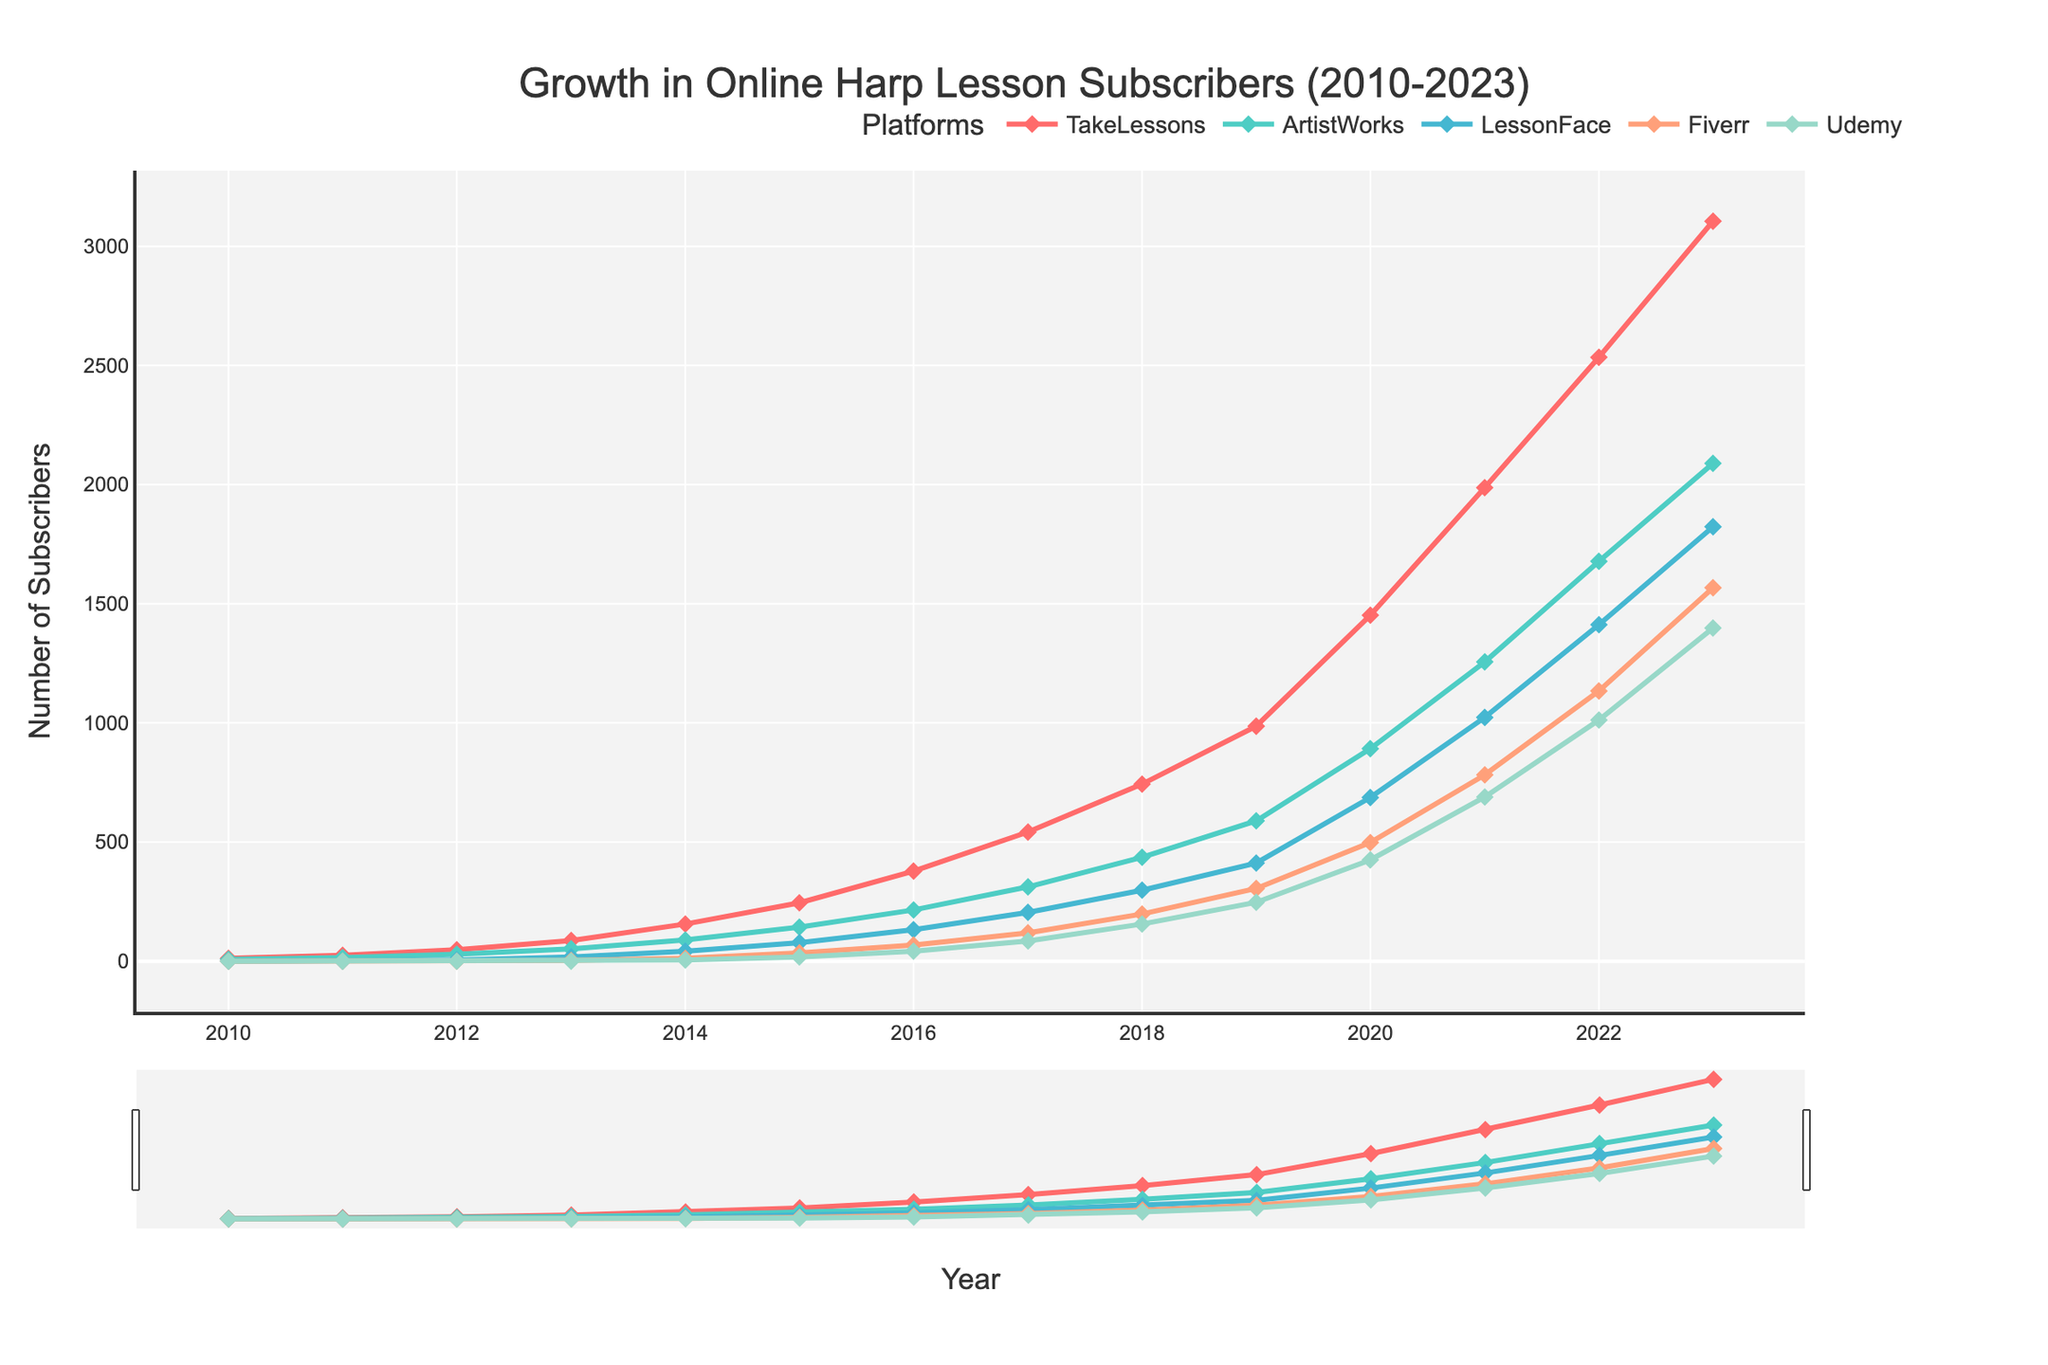What is the total number of subscribers for all platforms in 2023? Sum the subscribers for each platform in 2023: TakeLessons (3105), ArtistWorks (2089), LessonFace (1823), Fiverr (1567), Udemy (1398). Total = 3105 + 2089 + 1823 + 1567 + 1398 = 9982.
Answer: 9982 Which platform had the highest growth in subscribers between 2022 and 2023? Compare the increase in subscribers from 2022 to 2023 for all platforms. TakeLessons increased by 571 (3105-2534), ArtistWorks by 411 (2089-1678), LessonFace by 411 (1823-1412), Fiverr by 433 (1567-1134), and Udemy by 386 (1398-1012). Fiverr had the highest increase of 433 subscribers.
Answer: Fiverr Between which two consecutive years did TakeLessons see the largest growth? Calculate the differences between consecutive years for TakeLessons: 2011 (13), 2012 (23), 2013 (39), 2014 (69), 2015 (89), 2016 (133), 2017 (164), 2018 (201), 2019 (243), 2020 (466), 2021 (535), 2022 (547), 2023 (571). The largest growth was between 2019 and 2020 (466).
Answer: 2019 and 2020 Which platform had the lowest number of subscribers in 2010? Refer to the 2010 values for each platform: TakeLessons (12), ArtistWorks (8), LessonFace (0), Fiverr (0), Udemy (0). LessonFace, Fiverr, and Udemy all had 0 subscribers, so they tie for the lowest.
Answer: LessonFace, Fiverr, and Udemy How many more subscribers did LessonFace have in 2023 compared to 2015? Subtract LessonFace's 2015 subscribers from its 2023 subscribers: 1823 (2023) - 78 (2015) = 1745.
Answer: 1745 Which platform had a steady increase in subscribers every year from 2010 to 2023? Observe the lines for each platform. All platforms show consistent increases each year, but TakeLessons has the most linear and pronounced growth.
Answer: TakeLessons What is the average number of subscribers for ArtistWorks between 2010 and 2023? Sum the number of subscribers for ArtistWorks from 2010 to 2023 and divide by the number of years (14): (8 + 15 + 29 + 52 + 89 + 143 + 215 + 312 + 436 + 589 + 892 + 1256 + 1678 + 2089) / 14 = 762.14 (rounded to two decimal places).
Answer: 762.14 In which year did Fiverr surpass 1000 subscribers? Look at the Fiverr line and find the first year where it crosses 1000. It is in 2022.
Answer: 2022 How many subscribers did all platforms have together in 2017? Sum the number of subscribers for all platforms in 2017: TakeLessons (542), ArtistWorks (312), LessonFace (205), Fiverr (119), Udemy (85). Total = 542 + 312 + 205 + 119 + 85 = 1263.
Answer: 1263 